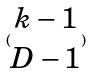Convert formula to latex. <formula><loc_0><loc_0><loc_500><loc_500>( \begin{matrix} k - 1 \\ D - 1 \end{matrix} )</formula> 